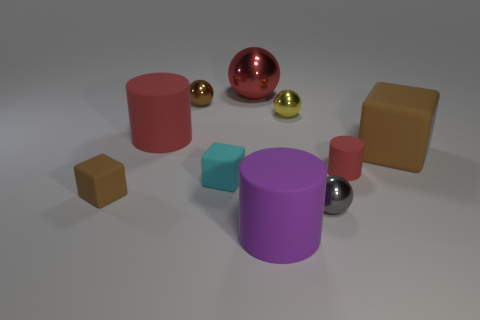Is there anything else of the same color as the large cube?
Your response must be concise. Yes. How many cubes are there?
Ensure brevity in your answer.  3. There is a matte object that is both on the right side of the small cyan cube and behind the small red cylinder; what is its shape?
Offer a terse response. Cube. There is a small metallic object that is behind the yellow metal ball that is in front of the small brown thing that is behind the cyan object; what is its shape?
Keep it short and to the point. Sphere. There is a object that is both in front of the small brown cube and behind the purple matte cylinder; what is it made of?
Your answer should be very brief. Metal. How many other shiny things are the same size as the purple thing?
Ensure brevity in your answer.  1. How many metal things are either purple objects or brown objects?
Keep it short and to the point. 1. What is the material of the brown sphere?
Ensure brevity in your answer.  Metal. What number of red cylinders are to the left of the yellow metallic ball?
Keep it short and to the point. 1. Are the big cylinder on the right side of the tiny brown sphere and the cyan thing made of the same material?
Make the answer very short. Yes. 